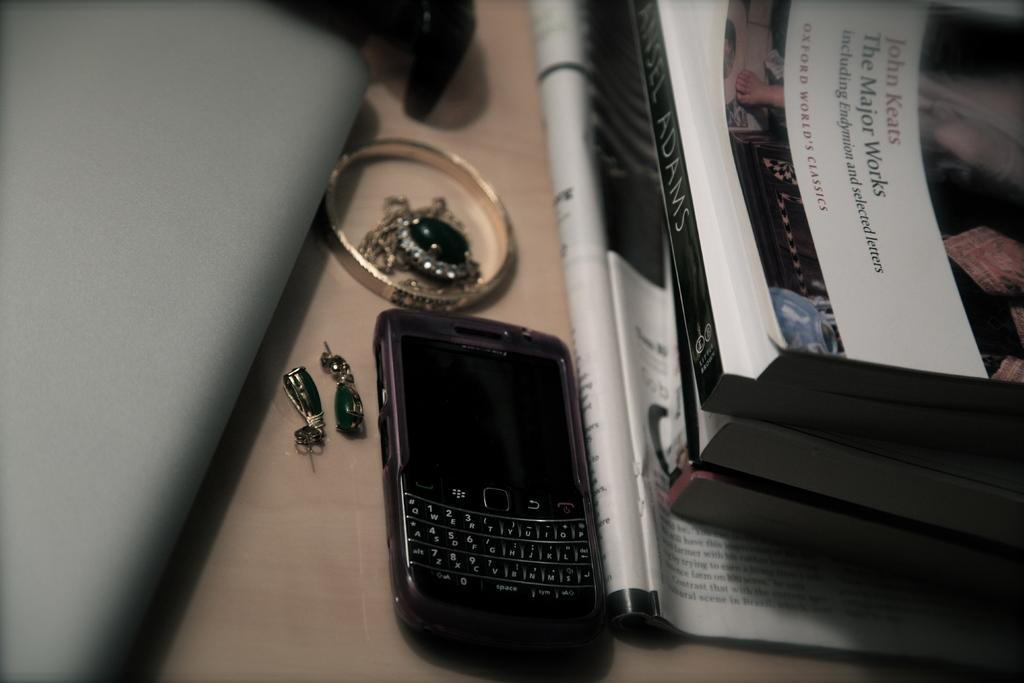<image>
Give a short and clear explanation of the subsequent image. A John Keats book is published by Oxford World's Classics. 